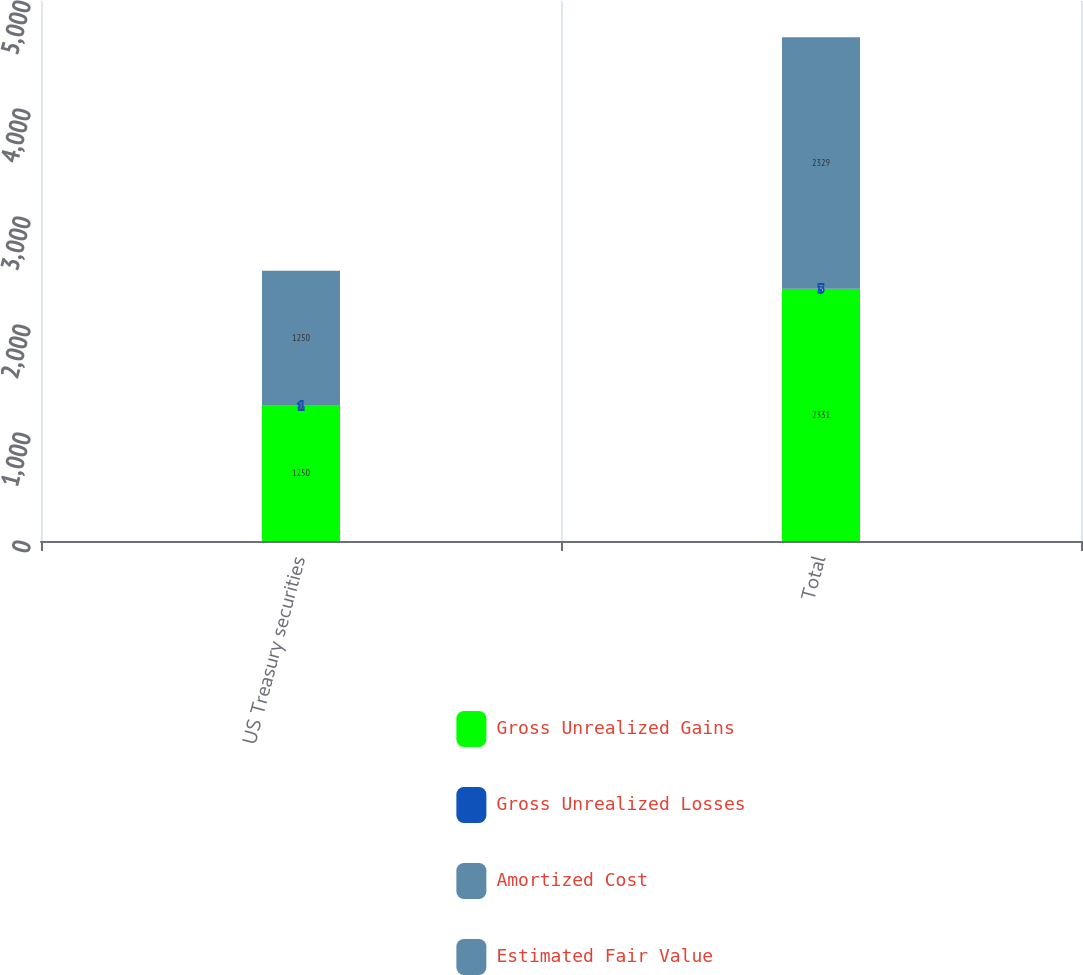<chart> <loc_0><loc_0><loc_500><loc_500><stacked_bar_chart><ecel><fcel>US Treasury securities<fcel>Total<nl><fcel>Gross Unrealized Gains<fcel>1250<fcel>2331<nl><fcel>Gross Unrealized Losses<fcel>1<fcel>3<nl><fcel>Amortized Cost<fcel>1<fcel>1<nl><fcel>Estimated Fair Value<fcel>1250<fcel>2329<nl></chart> 